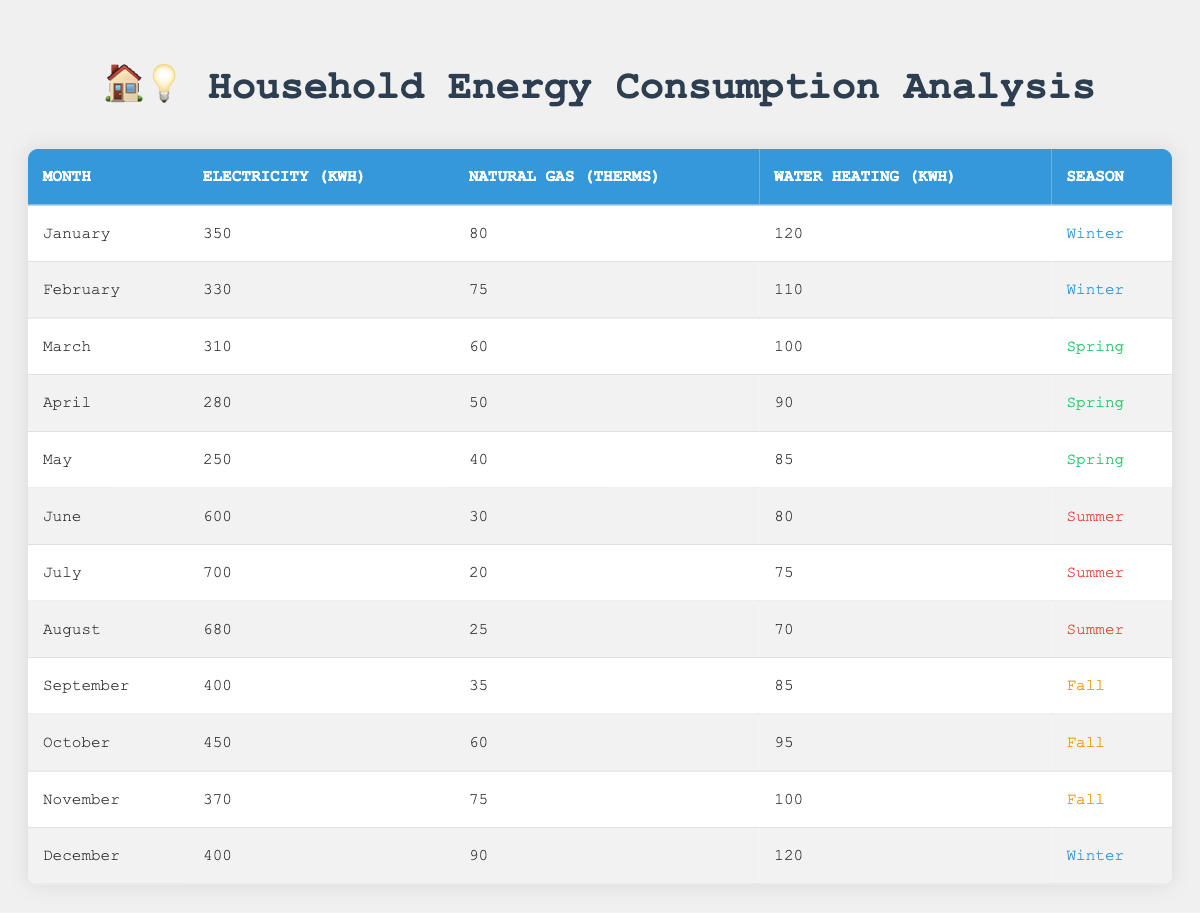What is the highest electricity consumption recorded in the table? The table shows that July has the highest electricity consumption at 700 kWh compared to any other month listed.
Answer: 700 kWh Which month shows the lowest natural gas consumption? By reviewing the table, we see that July has the lowest natural gas consumption at 20 therms, which is less than any other month.
Answer: July What is the average water heating consumption over the year? To find the average, add all the water heating values: (120 + 110 + 100 + 90 + 85 + 80 + 75 + 70 + 85 + 95 + 100 + 120) = 1,240. There are 12 months, so the average is 1,240 / 12 = 103.33.
Answer: 103.33 kWh Is the total electricity consumption higher in summer than in winter? For winter, the total electricity consumption is (350 + 330 + 400) = 1,080 kWh. For summer, it is (600 + 700 + 680) = 1,980 kWh. Since 1,980 is greater than 1,080, the answer is yes.
Answer: Yes What is the difference in water heating consumption between the highest and lowest months? The highest month for water heating is January with 120 kWh, and the lowest month is May with 85 kWh. The difference is 120 - 85 = 35.
Answer: 35 kWh How many months had natural gas consumption above 70 therms? By examining the table, we find January (80), February (75), October (60), and November (75). The only months that fulfill the criteria are January, February, and November, which totals three months.
Answer: 3 months Is it true that every month in summer had electricity consumption above 600 kWh? The table shows that June (600), July (700), and August (680) are all in summer. However, June just meets the criterion of above 600 kWh, so the statement is not true.
Answer: No What season had the highest total electricity consumption? Calculating totals: Winter = (350 + 330 + 400) = 1,080, Spring = (310 + 280 + 250) = 840, Summer = (600 + 700 + 680) = 1,980, Fall = (400 + 450 + 370) = 1,220. Summer has the highest total at 1,980 kWh.
Answer: Summer 